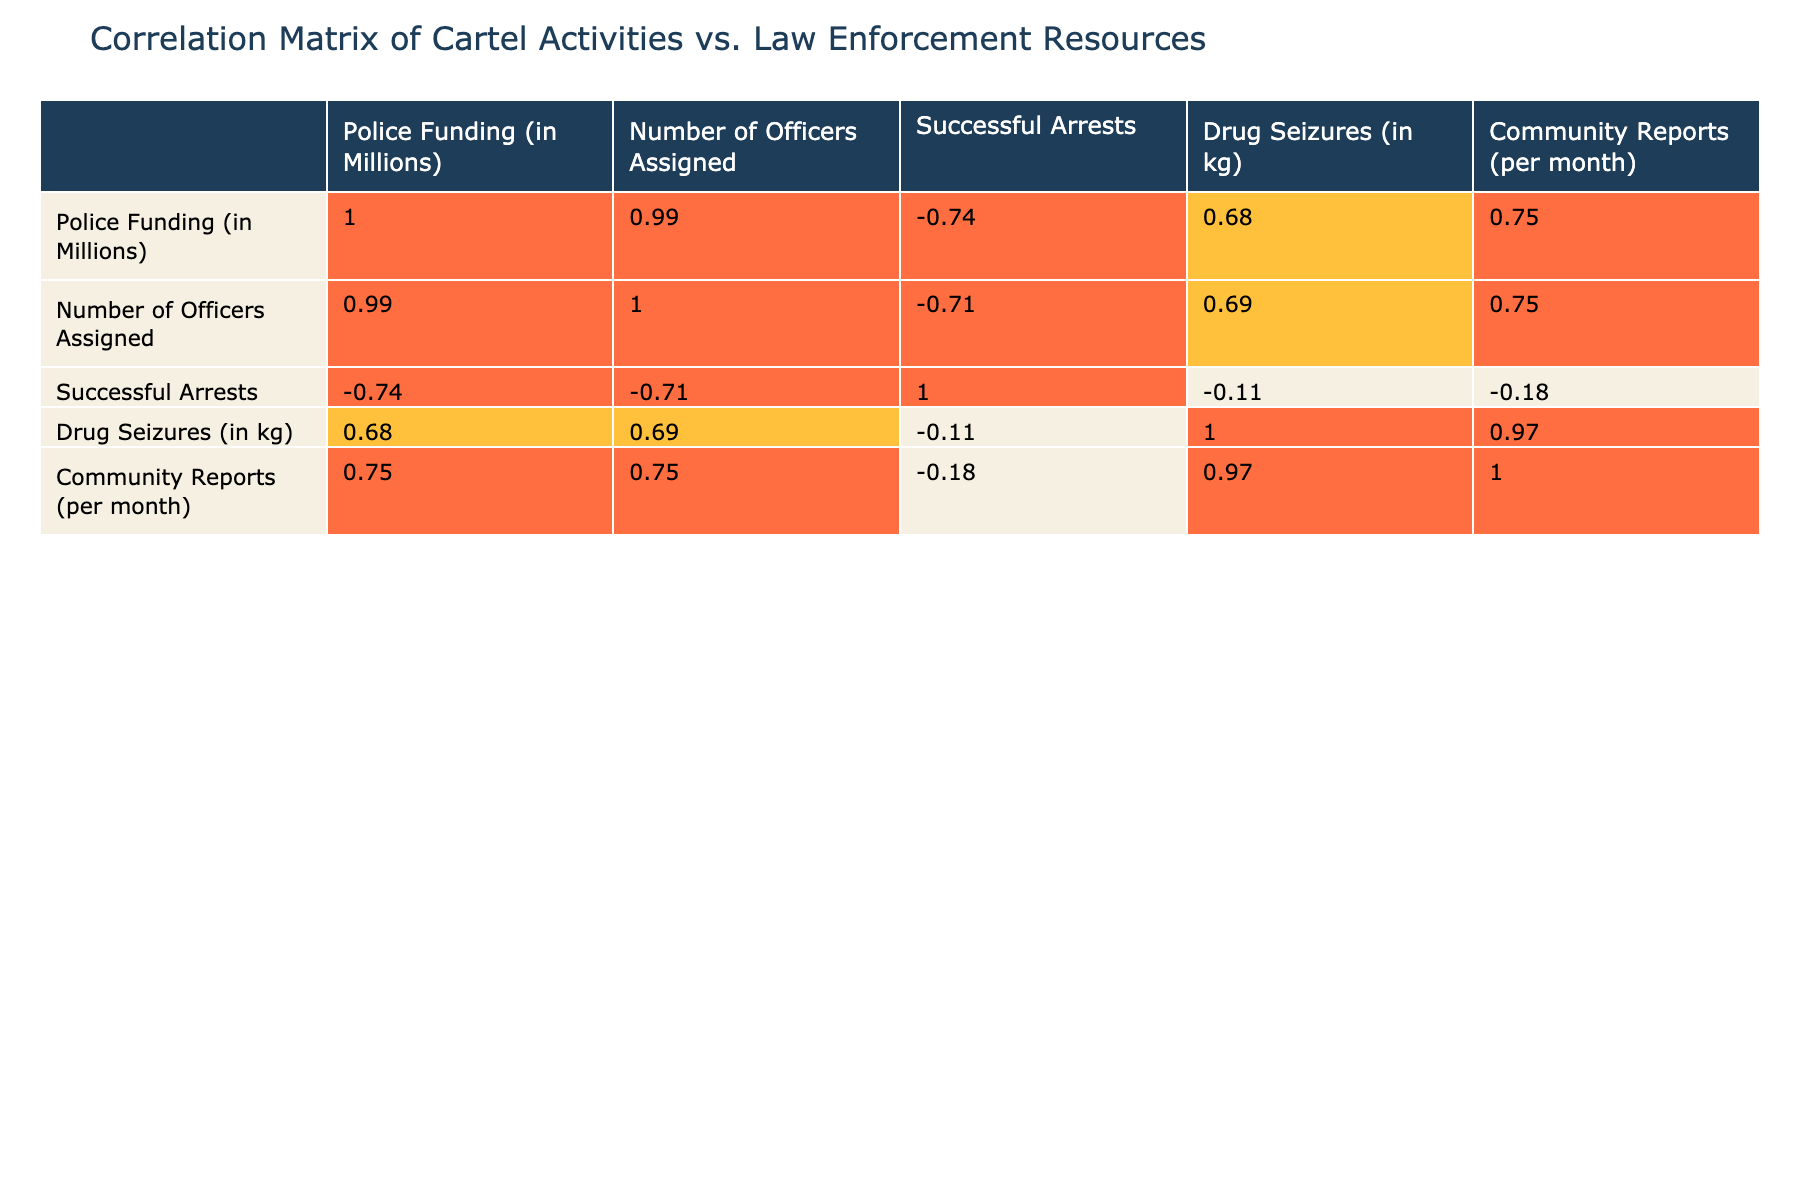What is the cartel activity level in California? From the table, we can directly read the value in the row corresponding to California under the "Cartel Activity Level (1-10)" column, which is 8.
Answer: 8 How many drug seizures were recorded in Arizona? Looking at the Arizona row in the table, the value under "Drug Seizures (in kg)" shows 2000.
Answer: 2000 Is there a correlation greater than 0.7 between police funding and successful arrests? From the correlation table, we check the row for "Police Funding (in Millions)" and look at the column for "Successful Arrests". The correlation value is 0.45, which is not greater than 0.7, indicating no strong correlation.
Answer: No What is the total police funding for the regions where the cartel activity level is 7? We identify the regions with a cartel activity level of 7, which are Texas and Illinois. Their respective police funding is 200 million and 180 million. Adding these gives us 200 + 180 = 380 million.
Answer: 380 million Is the number of officers assigned in New Mexico higher than that in Michigan? The number of officers in New Mexico is 7500, while in Michigan it is 8000. Since 7500 is less than 8000, New Mexico has fewer officers.
Answer: No What is the average drug seizure amount for regions with a cartel activity level of 8 and above? The regions with an activity level of 8 or above are California, Arizona, and New Mexico. The seizures for these regions are 1200 kg, 2000 kg, and 550 kg respectively. The total for these is 1200 + 2000 + 550 = 3750 kg. There are 3 regions, so the average is 3750 / 3 = 1250 kg.
Answer: 1250 kg Which region has the highest number of successful arrests? Looking through the "Successful Arrests" values, we find that Arizona has the highest number at 1800 successful arrests, surpassing others in the table.
Answer: Arizona How many community reports are filed per month in regions with drug seizures less than 600 kg? The regions with drug seizures under 600 kg are Florida, Michigan, and Washington, DC. Their respective community report numbers are 150, 125, and 100. Adding these gives us 150 + 125 + 100 = 375 reports per month.
Answer: 375 reports per month What is the correlation coefficient between the number of officers assigned and drug seizures? From the correlation table, the value for "Number of Officers Assigned" and "Drug Seizures (in kg)" indicates a correlation coefficient of 0.25. This indicates a weak positive correlation.
Answer: 0.25 